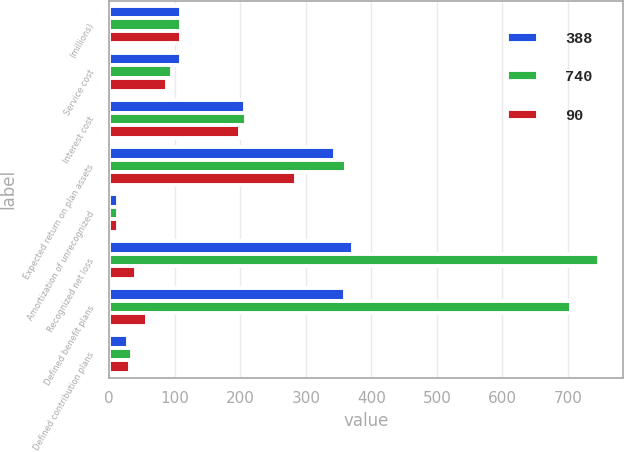Convert chart to OTSL. <chart><loc_0><loc_0><loc_500><loc_500><stacked_bar_chart><ecel><fcel>(millions)<fcel>Service cost<fcel>Interest cost<fcel>Expected return on plan assets<fcel>Amortization of unrecognized<fcel>Recognized net loss<fcel>Defined benefit plans<fcel>Defined contribution plans<nl><fcel>388<fcel>110<fcel>110<fcel>207<fcel>344<fcel>14<fcel>372<fcel>359<fcel>29<nl><fcel>740<fcel>110<fcel>96<fcel>209<fcel>361<fcel>14<fcel>747<fcel>705<fcel>35<nl><fcel>90<fcel>110<fcel>88<fcel>200<fcel>285<fcel>14<fcel>41<fcel>58<fcel>32<nl></chart> 